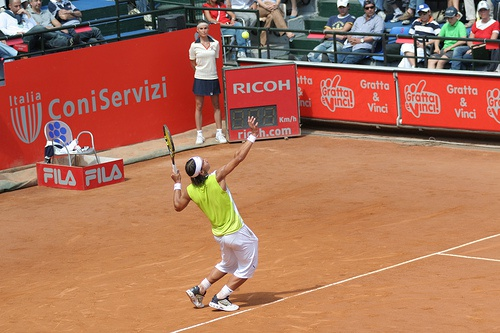Describe the objects in this image and their specific colors. I can see people in lightblue, tan, lavender, salmon, and darkgray tones, people in lightblue, lightgray, brown, black, and darkgray tones, people in lightblue, white, black, gray, and darkgray tones, people in lightblue, lavender, gray, black, and darkgray tones, and people in lightblue, gray, black, and blue tones in this image. 